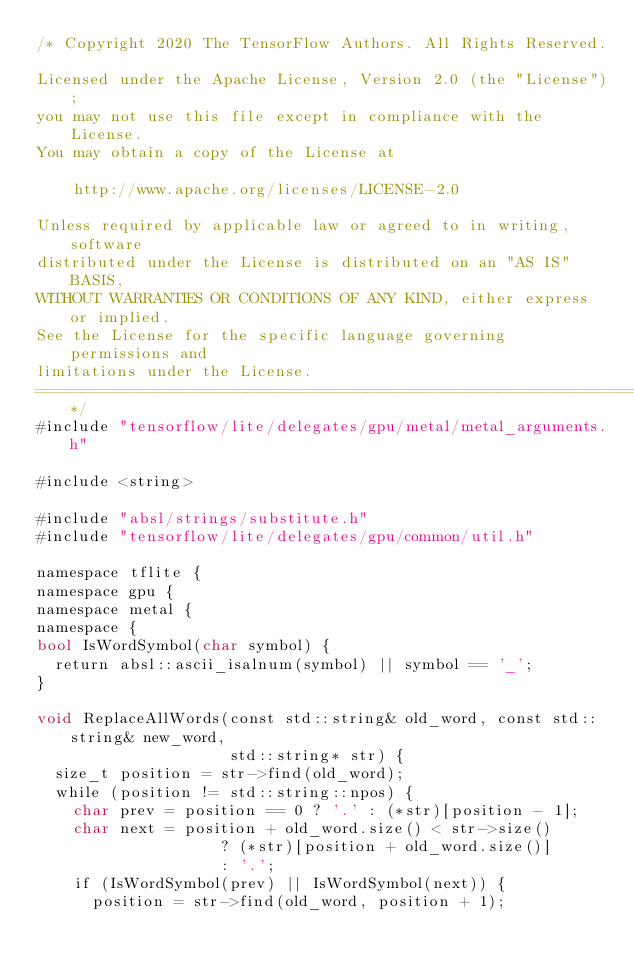Convert code to text. <code><loc_0><loc_0><loc_500><loc_500><_ObjectiveC_>/* Copyright 2020 The TensorFlow Authors. All Rights Reserved.

Licensed under the Apache License, Version 2.0 (the "License");
you may not use this file except in compliance with the License.
You may obtain a copy of the License at

    http://www.apache.org/licenses/LICENSE-2.0

Unless required by applicable law or agreed to in writing, software
distributed under the License is distributed on an "AS IS" BASIS,
WITHOUT WARRANTIES OR CONDITIONS OF ANY KIND, either express or implied.
See the License for the specific language governing permissions and
limitations under the License.
==============================================================================*/
#include "tensorflow/lite/delegates/gpu/metal/metal_arguments.h"

#include <string>

#include "absl/strings/substitute.h"
#include "tensorflow/lite/delegates/gpu/common/util.h"

namespace tflite {
namespace gpu {
namespace metal {
namespace {
bool IsWordSymbol(char symbol) {
  return absl::ascii_isalnum(symbol) || symbol == '_';
}

void ReplaceAllWords(const std::string& old_word, const std::string& new_word,
                     std::string* str) {
  size_t position = str->find(old_word);
  while (position != std::string::npos) {
    char prev = position == 0 ? '.' : (*str)[position - 1];
    char next = position + old_word.size() < str->size()
                    ? (*str)[position + old_word.size()]
                    : '.';
    if (IsWordSymbol(prev) || IsWordSymbol(next)) {
      position = str->find(old_word, position + 1);</code> 